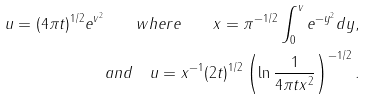Convert formula to latex. <formula><loc_0><loc_0><loc_500><loc_500>u = ( 4 \pi t ) ^ { 1 / 2 } e ^ { v ^ { 2 } } \quad w h e r e \quad x = \pi ^ { - 1 / 2 } \int _ { 0 } ^ { v } e ^ { - y ^ { 2 } } d y , \\ a n d \quad u = x ^ { - 1 } ( 2 t ) ^ { 1 / 2 } \left ( \ln \frac { 1 } { 4 \pi t x ^ { 2 } } \right ) ^ { - 1 / 2 } .</formula> 